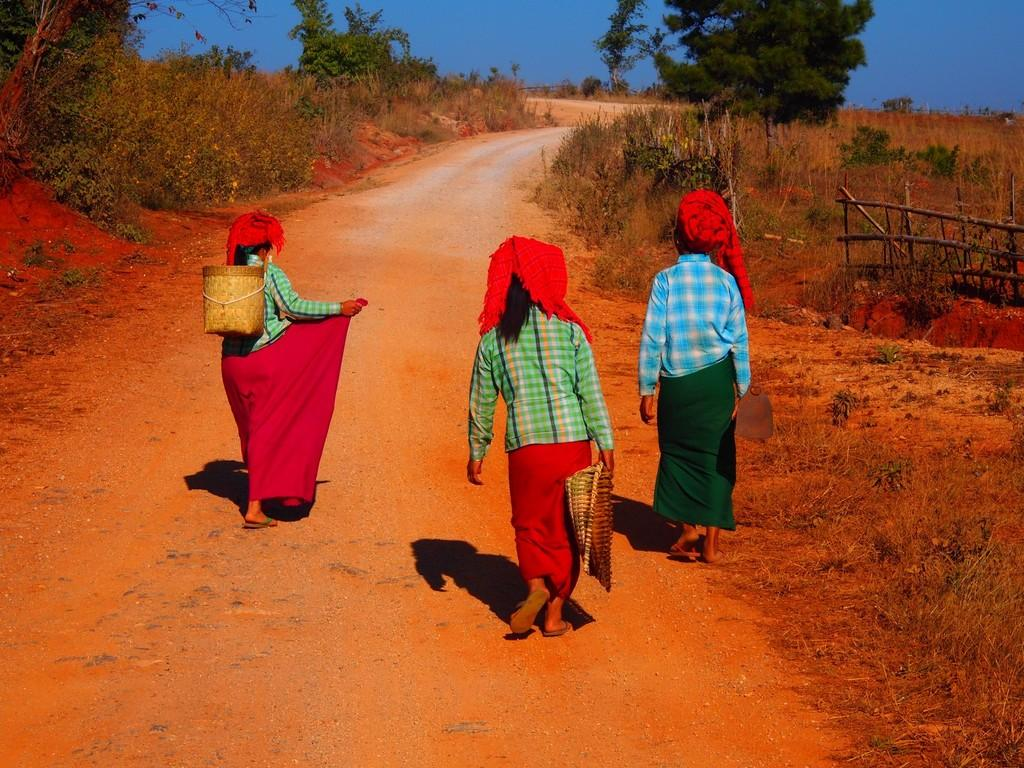How many people are in the image? There are three people in the image. What are the people doing in the image? The people are walking. What are the people wearing on their heads? The people are wearing baskets. What can be seen in the background of the image? There are trees in the background of the image. What is the condition of the sky in the image? The sky is clear in the image. What type of letters are the bears carrying in the image? There are no bears or letters present in the image. Is there a gate visible in the image? There is no gate visible in the image. 